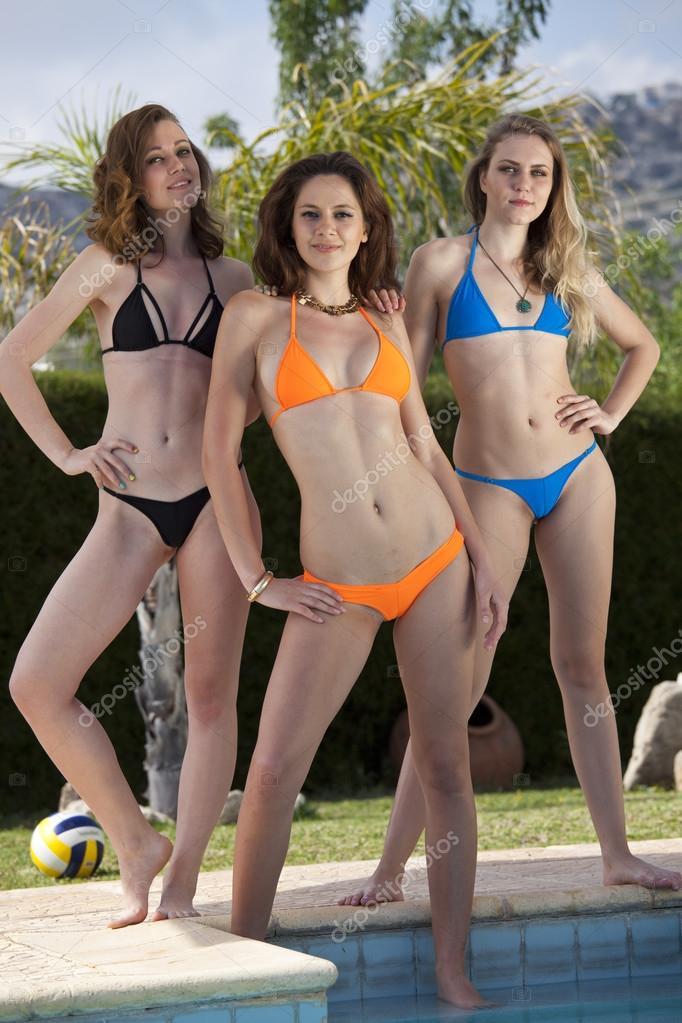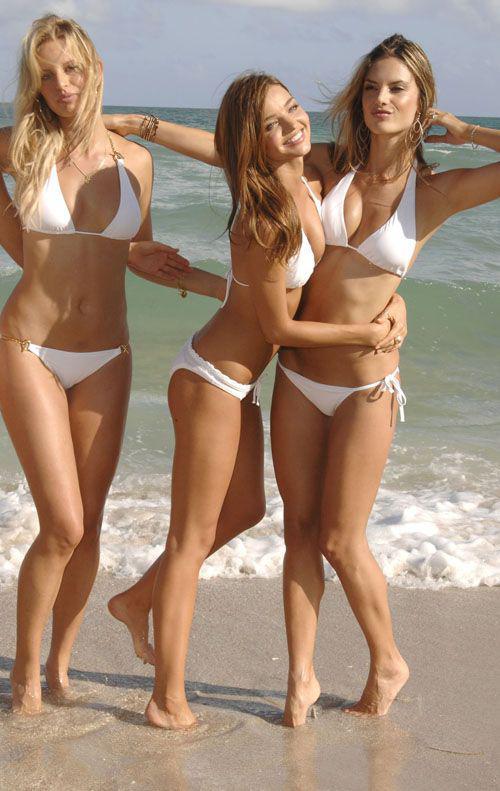The first image is the image on the left, the second image is the image on the right. For the images displayed, is the sentence "An image shows three bikini models, with the one on the far right wearing a polka-dotted black top." factually correct? Answer yes or no. No. 